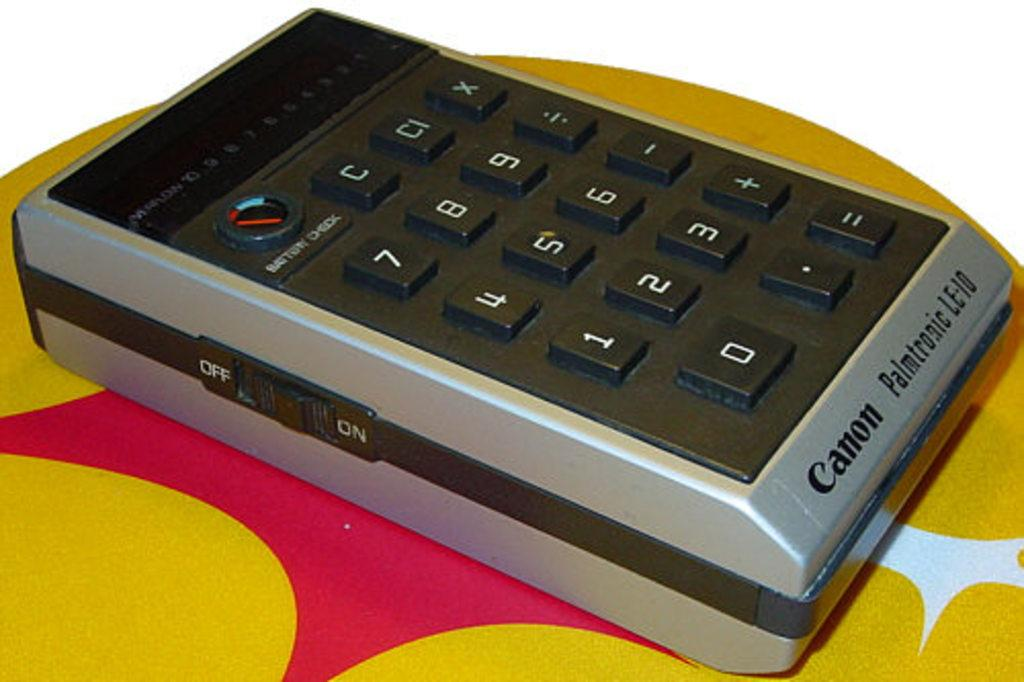<image>
Provide a brief description of the given image. A old calculator was made by the Canon company. 